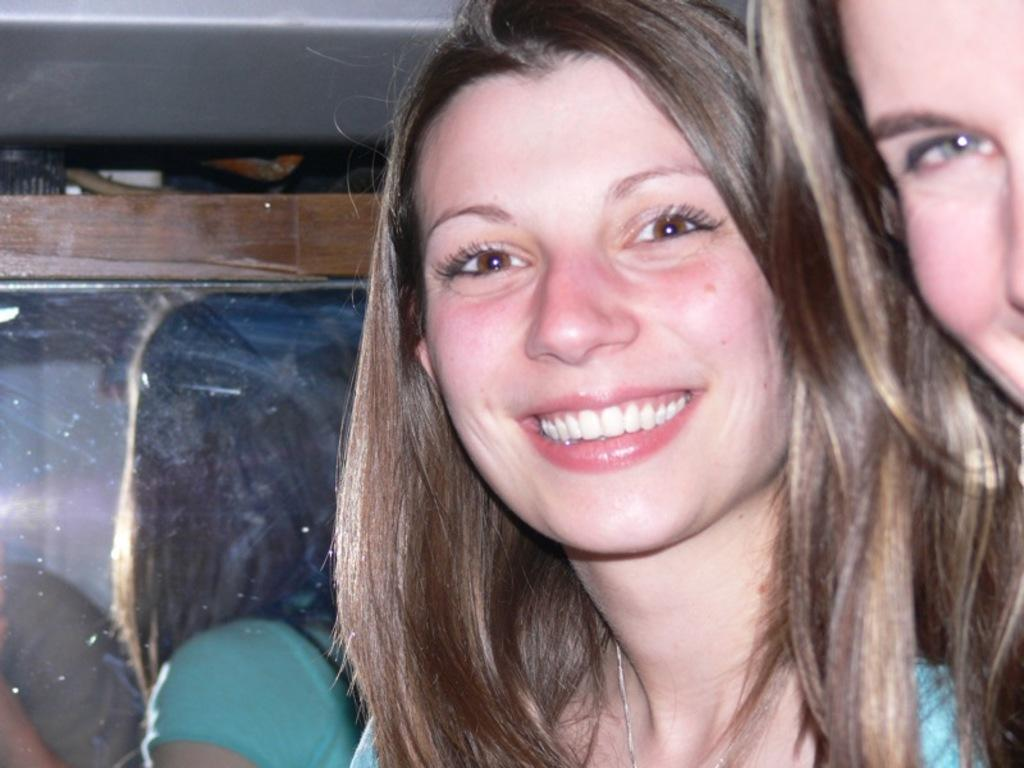Who is present in the image? There is a woman in the image. What is the woman doing in the image? The woman is smiling. What object is present in the image that has a wooden frame? There is a mirror with a wooden frame in the image. What does the mirror reflect in the image? The mirror reflects the image of a woman. Are there any other people visible in the image? Yes, there is another woman visible at the right side of the image. What flavor of cat food is being consumed by the cats in the image? There are no cats present in the image, so it is not possible to determine the flavor of cat food being consumed. 